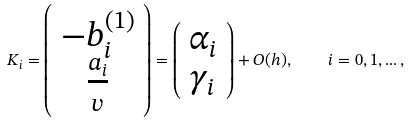<formula> <loc_0><loc_0><loc_500><loc_500>K _ { i } = \left ( \begin{array} { c } - b _ { i } ^ { ( 1 ) } \\ \frac { a _ { i } } { v } \end{array} \right ) = \left ( \begin{array} { c } \alpha _ { i } \\ \gamma _ { i } \end{array} \right ) + O ( h ) , \quad i = 0 , 1 , \dots ,</formula> 